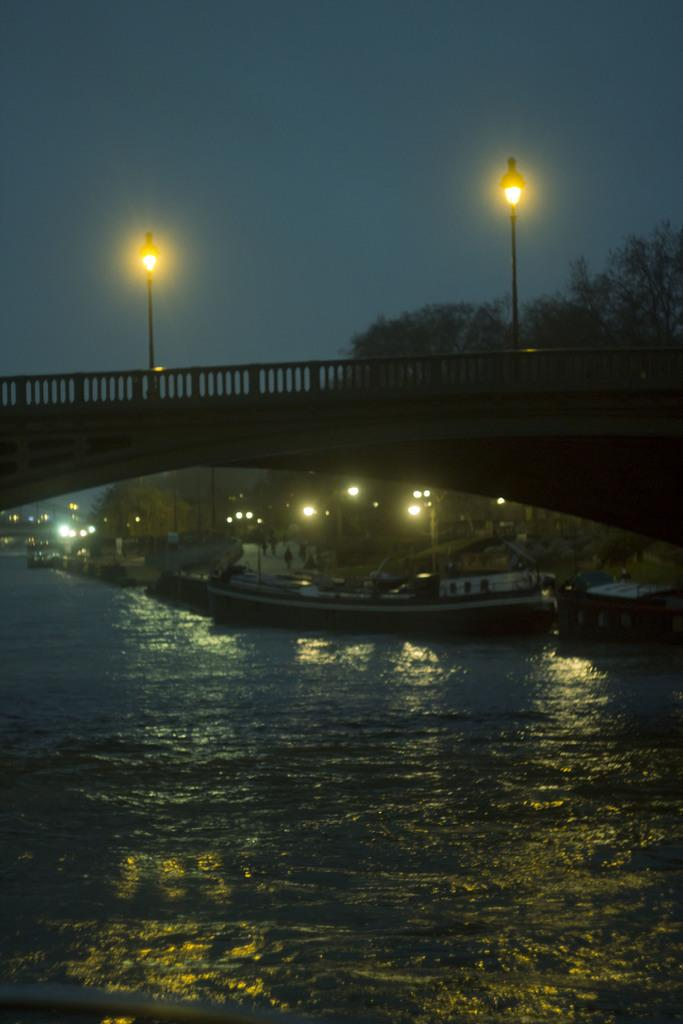What type of structure can be seen in the image? There is a bridge in the image. What are the poles with lights used for in the image? The poles with lights are likely used for illumination in the image. What type of vegetation is present in the image? There are trees in the image. What type of vehicles can be seen in the image? There are boats in the image. What type of pathway is visible in the image? There is a road in the image. What is visible at the bottom of the image? Water is visible at the bottom of the image. What is the condition of the sky in the background of the image? The sky is clear in the background of the image. How does the grip of the bee affect the image? There are no bees present in the image, so the grip of a bee cannot affect the image. What type of debt is associated with the water in the image? There is no mention of debt in the image, and the water is not associated with any financial obligations. 